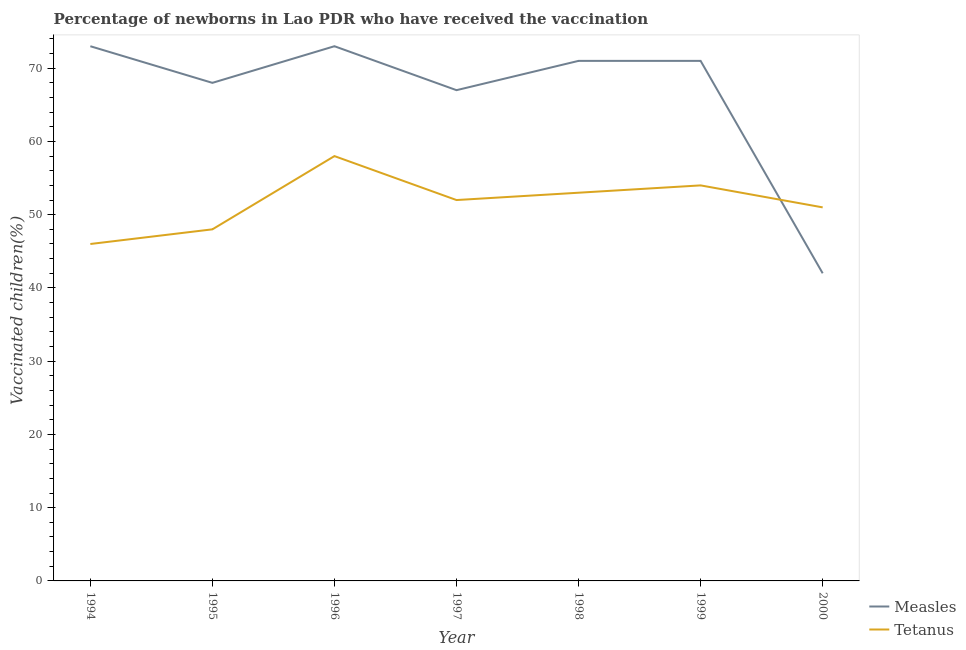How many different coloured lines are there?
Make the answer very short. 2. Does the line corresponding to percentage of newborns who received vaccination for measles intersect with the line corresponding to percentage of newborns who received vaccination for tetanus?
Your answer should be compact. Yes. Is the number of lines equal to the number of legend labels?
Give a very brief answer. Yes. What is the percentage of newborns who received vaccination for measles in 1997?
Your answer should be compact. 67. Across all years, what is the maximum percentage of newborns who received vaccination for tetanus?
Provide a succinct answer. 58. Across all years, what is the minimum percentage of newborns who received vaccination for measles?
Provide a succinct answer. 42. What is the total percentage of newborns who received vaccination for tetanus in the graph?
Offer a very short reply. 362. What is the difference between the percentage of newborns who received vaccination for tetanus in 1997 and the percentage of newborns who received vaccination for measles in 1999?
Your answer should be very brief. -19. What is the average percentage of newborns who received vaccination for tetanus per year?
Provide a succinct answer. 51.71. In the year 1999, what is the difference between the percentage of newborns who received vaccination for measles and percentage of newborns who received vaccination for tetanus?
Your answer should be very brief. 17. What is the ratio of the percentage of newborns who received vaccination for measles in 1994 to that in 1997?
Offer a terse response. 1.09. Is the percentage of newborns who received vaccination for tetanus in 1994 less than that in 2000?
Your answer should be compact. Yes. What is the difference between the highest and the second highest percentage of newborns who received vaccination for tetanus?
Keep it short and to the point. 4. What is the difference between the highest and the lowest percentage of newborns who received vaccination for measles?
Ensure brevity in your answer.  31. Is the sum of the percentage of newborns who received vaccination for tetanus in 1997 and 1999 greater than the maximum percentage of newborns who received vaccination for measles across all years?
Provide a short and direct response. Yes. Does the percentage of newborns who received vaccination for tetanus monotonically increase over the years?
Your answer should be compact. No. Is the percentage of newborns who received vaccination for measles strictly less than the percentage of newborns who received vaccination for tetanus over the years?
Offer a terse response. No. What is the difference between two consecutive major ticks on the Y-axis?
Give a very brief answer. 10. Are the values on the major ticks of Y-axis written in scientific E-notation?
Offer a terse response. No. Where does the legend appear in the graph?
Keep it short and to the point. Bottom right. How many legend labels are there?
Provide a succinct answer. 2. What is the title of the graph?
Ensure brevity in your answer.  Percentage of newborns in Lao PDR who have received the vaccination. What is the label or title of the X-axis?
Ensure brevity in your answer.  Year. What is the label or title of the Y-axis?
Your answer should be very brief. Vaccinated children(%)
. What is the Vaccinated children(%)
 in Tetanus in 1994?
Make the answer very short. 46. What is the Vaccinated children(%)
 of Tetanus in 1995?
Provide a short and direct response. 48. What is the Vaccinated children(%)
 of Tetanus in 1997?
Give a very brief answer. 52. What is the Vaccinated children(%)
 of Tetanus in 1998?
Provide a succinct answer. 53. Across all years, what is the maximum Vaccinated children(%)
 in Measles?
Offer a very short reply. 73. Across all years, what is the maximum Vaccinated children(%)
 in Tetanus?
Keep it short and to the point. 58. What is the total Vaccinated children(%)
 in Measles in the graph?
Provide a succinct answer. 465. What is the total Vaccinated children(%)
 in Tetanus in the graph?
Your answer should be very brief. 362. What is the difference between the Vaccinated children(%)
 in Measles in 1994 and that in 1995?
Keep it short and to the point. 5. What is the difference between the Vaccinated children(%)
 of Tetanus in 1994 and that in 1995?
Your answer should be compact. -2. What is the difference between the Vaccinated children(%)
 of Measles in 1994 and that in 1997?
Give a very brief answer. 6. What is the difference between the Vaccinated children(%)
 in Tetanus in 1994 and that in 1997?
Provide a short and direct response. -6. What is the difference between the Vaccinated children(%)
 of Measles in 1994 and that in 1998?
Your answer should be compact. 2. What is the difference between the Vaccinated children(%)
 in Measles in 1994 and that in 2000?
Offer a very short reply. 31. What is the difference between the Vaccinated children(%)
 of Measles in 1995 and that in 1996?
Give a very brief answer. -5. What is the difference between the Vaccinated children(%)
 in Tetanus in 1995 and that in 1998?
Your response must be concise. -5. What is the difference between the Vaccinated children(%)
 in Measles in 1995 and that in 1999?
Keep it short and to the point. -3. What is the difference between the Vaccinated children(%)
 in Tetanus in 1995 and that in 1999?
Provide a succinct answer. -6. What is the difference between the Vaccinated children(%)
 in Measles in 1995 and that in 2000?
Make the answer very short. 26. What is the difference between the Vaccinated children(%)
 in Tetanus in 1995 and that in 2000?
Offer a terse response. -3. What is the difference between the Vaccinated children(%)
 of Measles in 1996 and that in 1997?
Keep it short and to the point. 6. What is the difference between the Vaccinated children(%)
 of Tetanus in 1996 and that in 1999?
Your answer should be compact. 4. What is the difference between the Vaccinated children(%)
 in Measles in 1997 and that in 2000?
Your answer should be very brief. 25. What is the difference between the Vaccinated children(%)
 of Measles in 1998 and that in 1999?
Provide a short and direct response. 0. What is the difference between the Vaccinated children(%)
 in Measles in 1998 and that in 2000?
Provide a succinct answer. 29. What is the difference between the Vaccinated children(%)
 of Tetanus in 1998 and that in 2000?
Ensure brevity in your answer.  2. What is the difference between the Vaccinated children(%)
 of Measles in 1999 and that in 2000?
Your answer should be very brief. 29. What is the difference between the Vaccinated children(%)
 of Tetanus in 1999 and that in 2000?
Your answer should be very brief. 3. What is the difference between the Vaccinated children(%)
 in Measles in 1994 and the Vaccinated children(%)
 in Tetanus in 1995?
Provide a short and direct response. 25. What is the difference between the Vaccinated children(%)
 in Measles in 1994 and the Vaccinated children(%)
 in Tetanus in 1996?
Keep it short and to the point. 15. What is the difference between the Vaccinated children(%)
 of Measles in 1994 and the Vaccinated children(%)
 of Tetanus in 1999?
Ensure brevity in your answer.  19. What is the difference between the Vaccinated children(%)
 of Measles in 1995 and the Vaccinated children(%)
 of Tetanus in 1997?
Provide a succinct answer. 16. What is the difference between the Vaccinated children(%)
 of Measles in 1996 and the Vaccinated children(%)
 of Tetanus in 1998?
Ensure brevity in your answer.  20. What is the difference between the Vaccinated children(%)
 of Measles in 1996 and the Vaccinated children(%)
 of Tetanus in 1999?
Your answer should be compact. 19. What is the difference between the Vaccinated children(%)
 of Measles in 1996 and the Vaccinated children(%)
 of Tetanus in 2000?
Make the answer very short. 22. What is the difference between the Vaccinated children(%)
 in Measles in 1999 and the Vaccinated children(%)
 in Tetanus in 2000?
Offer a very short reply. 20. What is the average Vaccinated children(%)
 in Measles per year?
Provide a short and direct response. 66.43. What is the average Vaccinated children(%)
 of Tetanus per year?
Keep it short and to the point. 51.71. In the year 1996, what is the difference between the Vaccinated children(%)
 of Measles and Vaccinated children(%)
 of Tetanus?
Keep it short and to the point. 15. In the year 1997, what is the difference between the Vaccinated children(%)
 in Measles and Vaccinated children(%)
 in Tetanus?
Make the answer very short. 15. In the year 1998, what is the difference between the Vaccinated children(%)
 in Measles and Vaccinated children(%)
 in Tetanus?
Make the answer very short. 18. In the year 1999, what is the difference between the Vaccinated children(%)
 in Measles and Vaccinated children(%)
 in Tetanus?
Offer a terse response. 17. What is the ratio of the Vaccinated children(%)
 of Measles in 1994 to that in 1995?
Your answer should be very brief. 1.07. What is the ratio of the Vaccinated children(%)
 in Tetanus in 1994 to that in 1996?
Your answer should be very brief. 0.79. What is the ratio of the Vaccinated children(%)
 in Measles in 1994 to that in 1997?
Provide a short and direct response. 1.09. What is the ratio of the Vaccinated children(%)
 in Tetanus in 1994 to that in 1997?
Keep it short and to the point. 0.88. What is the ratio of the Vaccinated children(%)
 in Measles in 1994 to that in 1998?
Keep it short and to the point. 1.03. What is the ratio of the Vaccinated children(%)
 in Tetanus in 1994 to that in 1998?
Provide a succinct answer. 0.87. What is the ratio of the Vaccinated children(%)
 of Measles in 1994 to that in 1999?
Provide a short and direct response. 1.03. What is the ratio of the Vaccinated children(%)
 of Tetanus in 1994 to that in 1999?
Ensure brevity in your answer.  0.85. What is the ratio of the Vaccinated children(%)
 of Measles in 1994 to that in 2000?
Make the answer very short. 1.74. What is the ratio of the Vaccinated children(%)
 of Tetanus in 1994 to that in 2000?
Your answer should be very brief. 0.9. What is the ratio of the Vaccinated children(%)
 in Measles in 1995 to that in 1996?
Your answer should be very brief. 0.93. What is the ratio of the Vaccinated children(%)
 in Tetanus in 1995 to that in 1996?
Provide a succinct answer. 0.83. What is the ratio of the Vaccinated children(%)
 in Measles in 1995 to that in 1997?
Your answer should be very brief. 1.01. What is the ratio of the Vaccinated children(%)
 of Measles in 1995 to that in 1998?
Give a very brief answer. 0.96. What is the ratio of the Vaccinated children(%)
 in Tetanus in 1995 to that in 1998?
Offer a very short reply. 0.91. What is the ratio of the Vaccinated children(%)
 of Measles in 1995 to that in 1999?
Your response must be concise. 0.96. What is the ratio of the Vaccinated children(%)
 of Tetanus in 1995 to that in 1999?
Offer a very short reply. 0.89. What is the ratio of the Vaccinated children(%)
 of Measles in 1995 to that in 2000?
Give a very brief answer. 1.62. What is the ratio of the Vaccinated children(%)
 of Measles in 1996 to that in 1997?
Give a very brief answer. 1.09. What is the ratio of the Vaccinated children(%)
 in Tetanus in 1996 to that in 1997?
Your answer should be compact. 1.12. What is the ratio of the Vaccinated children(%)
 of Measles in 1996 to that in 1998?
Offer a terse response. 1.03. What is the ratio of the Vaccinated children(%)
 of Tetanus in 1996 to that in 1998?
Your answer should be compact. 1.09. What is the ratio of the Vaccinated children(%)
 of Measles in 1996 to that in 1999?
Offer a very short reply. 1.03. What is the ratio of the Vaccinated children(%)
 of Tetanus in 1996 to that in 1999?
Keep it short and to the point. 1.07. What is the ratio of the Vaccinated children(%)
 of Measles in 1996 to that in 2000?
Keep it short and to the point. 1.74. What is the ratio of the Vaccinated children(%)
 of Tetanus in 1996 to that in 2000?
Offer a terse response. 1.14. What is the ratio of the Vaccinated children(%)
 of Measles in 1997 to that in 1998?
Make the answer very short. 0.94. What is the ratio of the Vaccinated children(%)
 in Tetanus in 1997 to that in 1998?
Provide a short and direct response. 0.98. What is the ratio of the Vaccinated children(%)
 of Measles in 1997 to that in 1999?
Ensure brevity in your answer.  0.94. What is the ratio of the Vaccinated children(%)
 in Tetanus in 1997 to that in 1999?
Your answer should be compact. 0.96. What is the ratio of the Vaccinated children(%)
 in Measles in 1997 to that in 2000?
Offer a terse response. 1.6. What is the ratio of the Vaccinated children(%)
 of Tetanus in 1997 to that in 2000?
Make the answer very short. 1.02. What is the ratio of the Vaccinated children(%)
 in Measles in 1998 to that in 1999?
Provide a short and direct response. 1. What is the ratio of the Vaccinated children(%)
 of Tetanus in 1998 to that in 1999?
Give a very brief answer. 0.98. What is the ratio of the Vaccinated children(%)
 in Measles in 1998 to that in 2000?
Keep it short and to the point. 1.69. What is the ratio of the Vaccinated children(%)
 in Tetanus in 1998 to that in 2000?
Offer a terse response. 1.04. What is the ratio of the Vaccinated children(%)
 in Measles in 1999 to that in 2000?
Offer a very short reply. 1.69. What is the ratio of the Vaccinated children(%)
 in Tetanus in 1999 to that in 2000?
Offer a very short reply. 1.06. What is the difference between the highest and the lowest Vaccinated children(%)
 of Measles?
Provide a short and direct response. 31. 